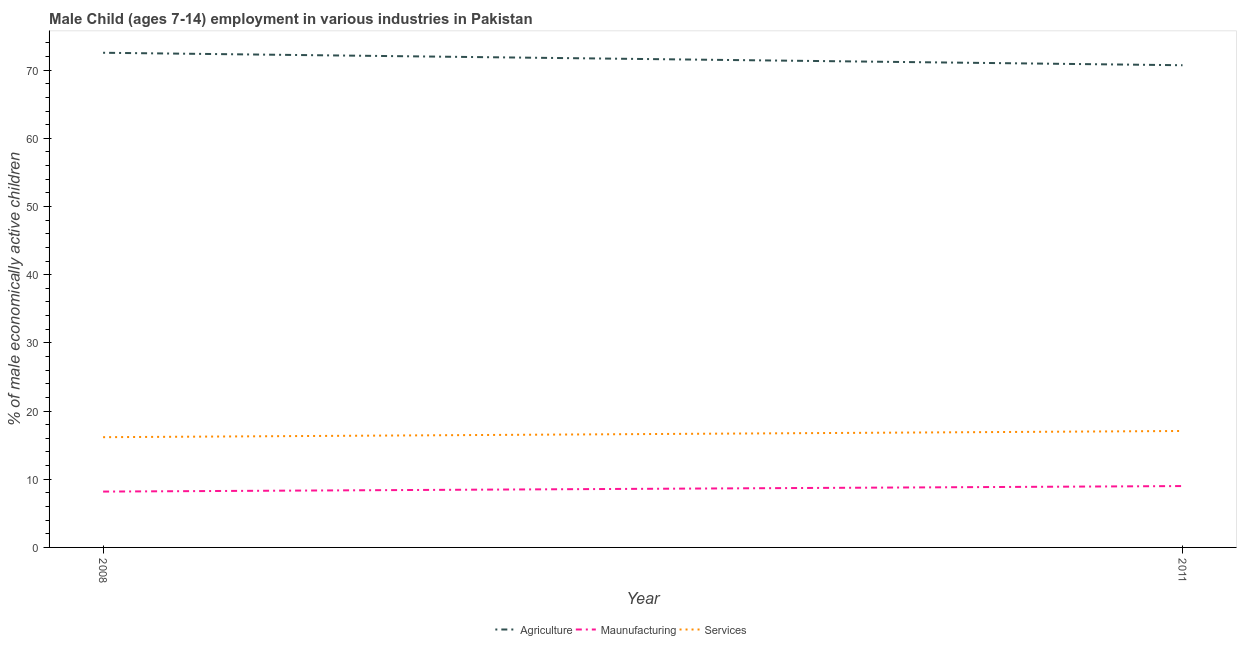Does the line corresponding to percentage of economically active children in manufacturing intersect with the line corresponding to percentage of economically active children in services?
Your answer should be very brief. No. What is the percentage of economically active children in services in 2008?
Keep it short and to the point. 16.17. Across all years, what is the maximum percentage of economically active children in services?
Your answer should be compact. 17.08. Across all years, what is the minimum percentage of economically active children in agriculture?
Your answer should be compact. 70.72. In which year was the percentage of economically active children in manufacturing maximum?
Give a very brief answer. 2011. What is the total percentage of economically active children in services in the graph?
Give a very brief answer. 33.25. What is the difference between the percentage of economically active children in agriculture in 2008 and that in 2011?
Your response must be concise. 1.83. What is the difference between the percentage of economically active children in agriculture in 2008 and the percentage of economically active children in manufacturing in 2011?
Keep it short and to the point. 63.55. What is the average percentage of economically active children in manufacturing per year?
Keep it short and to the point. 8.59. In the year 2011, what is the difference between the percentage of economically active children in agriculture and percentage of economically active children in manufacturing?
Keep it short and to the point. 61.72. What is the ratio of the percentage of economically active children in manufacturing in 2008 to that in 2011?
Make the answer very short. 0.91. Is the percentage of economically active children in services in 2008 less than that in 2011?
Your answer should be compact. Yes. In how many years, is the percentage of economically active children in services greater than the average percentage of economically active children in services taken over all years?
Offer a very short reply. 1. Is it the case that in every year, the sum of the percentage of economically active children in agriculture and percentage of economically active children in manufacturing is greater than the percentage of economically active children in services?
Offer a very short reply. Yes. Does the percentage of economically active children in agriculture monotonically increase over the years?
Give a very brief answer. No. Is the percentage of economically active children in agriculture strictly greater than the percentage of economically active children in manufacturing over the years?
Provide a succinct answer. Yes. How many lines are there?
Provide a succinct answer. 3. How many years are there in the graph?
Give a very brief answer. 2. Are the values on the major ticks of Y-axis written in scientific E-notation?
Keep it short and to the point. No. Does the graph contain grids?
Your answer should be very brief. No. How many legend labels are there?
Provide a short and direct response. 3. How are the legend labels stacked?
Your answer should be compact. Horizontal. What is the title of the graph?
Your response must be concise. Male Child (ages 7-14) employment in various industries in Pakistan. What is the label or title of the Y-axis?
Make the answer very short. % of male economically active children. What is the % of male economically active children in Agriculture in 2008?
Offer a very short reply. 72.55. What is the % of male economically active children in Maunufacturing in 2008?
Provide a short and direct response. 8.19. What is the % of male economically active children in Services in 2008?
Ensure brevity in your answer.  16.17. What is the % of male economically active children of Agriculture in 2011?
Your answer should be very brief. 70.72. What is the % of male economically active children in Services in 2011?
Keep it short and to the point. 17.08. Across all years, what is the maximum % of male economically active children of Agriculture?
Make the answer very short. 72.55. Across all years, what is the maximum % of male economically active children of Services?
Offer a very short reply. 17.08. Across all years, what is the minimum % of male economically active children in Agriculture?
Provide a succinct answer. 70.72. Across all years, what is the minimum % of male economically active children of Maunufacturing?
Offer a terse response. 8.19. Across all years, what is the minimum % of male economically active children of Services?
Your answer should be very brief. 16.17. What is the total % of male economically active children in Agriculture in the graph?
Keep it short and to the point. 143.27. What is the total % of male economically active children in Maunufacturing in the graph?
Your answer should be very brief. 17.19. What is the total % of male economically active children of Services in the graph?
Make the answer very short. 33.25. What is the difference between the % of male economically active children in Agriculture in 2008 and that in 2011?
Provide a succinct answer. 1.83. What is the difference between the % of male economically active children of Maunufacturing in 2008 and that in 2011?
Keep it short and to the point. -0.81. What is the difference between the % of male economically active children in Services in 2008 and that in 2011?
Offer a terse response. -0.91. What is the difference between the % of male economically active children of Agriculture in 2008 and the % of male economically active children of Maunufacturing in 2011?
Your response must be concise. 63.55. What is the difference between the % of male economically active children of Agriculture in 2008 and the % of male economically active children of Services in 2011?
Give a very brief answer. 55.47. What is the difference between the % of male economically active children of Maunufacturing in 2008 and the % of male economically active children of Services in 2011?
Provide a short and direct response. -8.89. What is the average % of male economically active children of Agriculture per year?
Provide a succinct answer. 71.64. What is the average % of male economically active children in Maunufacturing per year?
Keep it short and to the point. 8.6. What is the average % of male economically active children in Services per year?
Offer a very short reply. 16.62. In the year 2008, what is the difference between the % of male economically active children of Agriculture and % of male economically active children of Maunufacturing?
Your answer should be compact. 64.36. In the year 2008, what is the difference between the % of male economically active children of Agriculture and % of male economically active children of Services?
Keep it short and to the point. 56.38. In the year 2008, what is the difference between the % of male economically active children of Maunufacturing and % of male economically active children of Services?
Your answer should be compact. -7.98. In the year 2011, what is the difference between the % of male economically active children in Agriculture and % of male economically active children in Maunufacturing?
Your answer should be compact. 61.72. In the year 2011, what is the difference between the % of male economically active children of Agriculture and % of male economically active children of Services?
Offer a very short reply. 53.64. In the year 2011, what is the difference between the % of male economically active children in Maunufacturing and % of male economically active children in Services?
Ensure brevity in your answer.  -8.08. What is the ratio of the % of male economically active children in Agriculture in 2008 to that in 2011?
Make the answer very short. 1.03. What is the ratio of the % of male economically active children in Maunufacturing in 2008 to that in 2011?
Offer a terse response. 0.91. What is the ratio of the % of male economically active children of Services in 2008 to that in 2011?
Make the answer very short. 0.95. What is the difference between the highest and the second highest % of male economically active children in Agriculture?
Ensure brevity in your answer.  1.83. What is the difference between the highest and the second highest % of male economically active children of Maunufacturing?
Offer a very short reply. 0.81. What is the difference between the highest and the second highest % of male economically active children in Services?
Your answer should be very brief. 0.91. What is the difference between the highest and the lowest % of male economically active children in Agriculture?
Offer a terse response. 1.83. What is the difference between the highest and the lowest % of male economically active children in Maunufacturing?
Ensure brevity in your answer.  0.81. What is the difference between the highest and the lowest % of male economically active children in Services?
Offer a terse response. 0.91. 